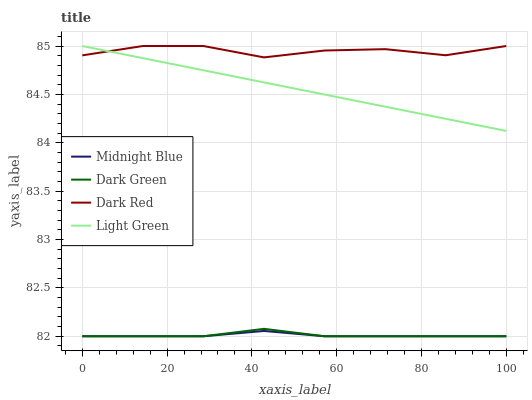Does Midnight Blue have the minimum area under the curve?
Answer yes or no. Yes. Does Dark Red have the maximum area under the curve?
Answer yes or no. Yes. Does Light Green have the minimum area under the curve?
Answer yes or no. No. Does Light Green have the maximum area under the curve?
Answer yes or no. No. Is Light Green the smoothest?
Answer yes or no. Yes. Is Dark Red the roughest?
Answer yes or no. Yes. Is Midnight Blue the smoothest?
Answer yes or no. No. Is Midnight Blue the roughest?
Answer yes or no. No. Does Midnight Blue have the lowest value?
Answer yes or no. Yes. Does Light Green have the lowest value?
Answer yes or no. No. Does Light Green have the highest value?
Answer yes or no. Yes. Does Midnight Blue have the highest value?
Answer yes or no. No. Is Dark Green less than Light Green?
Answer yes or no. Yes. Is Dark Red greater than Midnight Blue?
Answer yes or no. Yes. Does Dark Red intersect Light Green?
Answer yes or no. Yes. Is Dark Red less than Light Green?
Answer yes or no. No. Is Dark Red greater than Light Green?
Answer yes or no. No. Does Dark Green intersect Light Green?
Answer yes or no. No. 